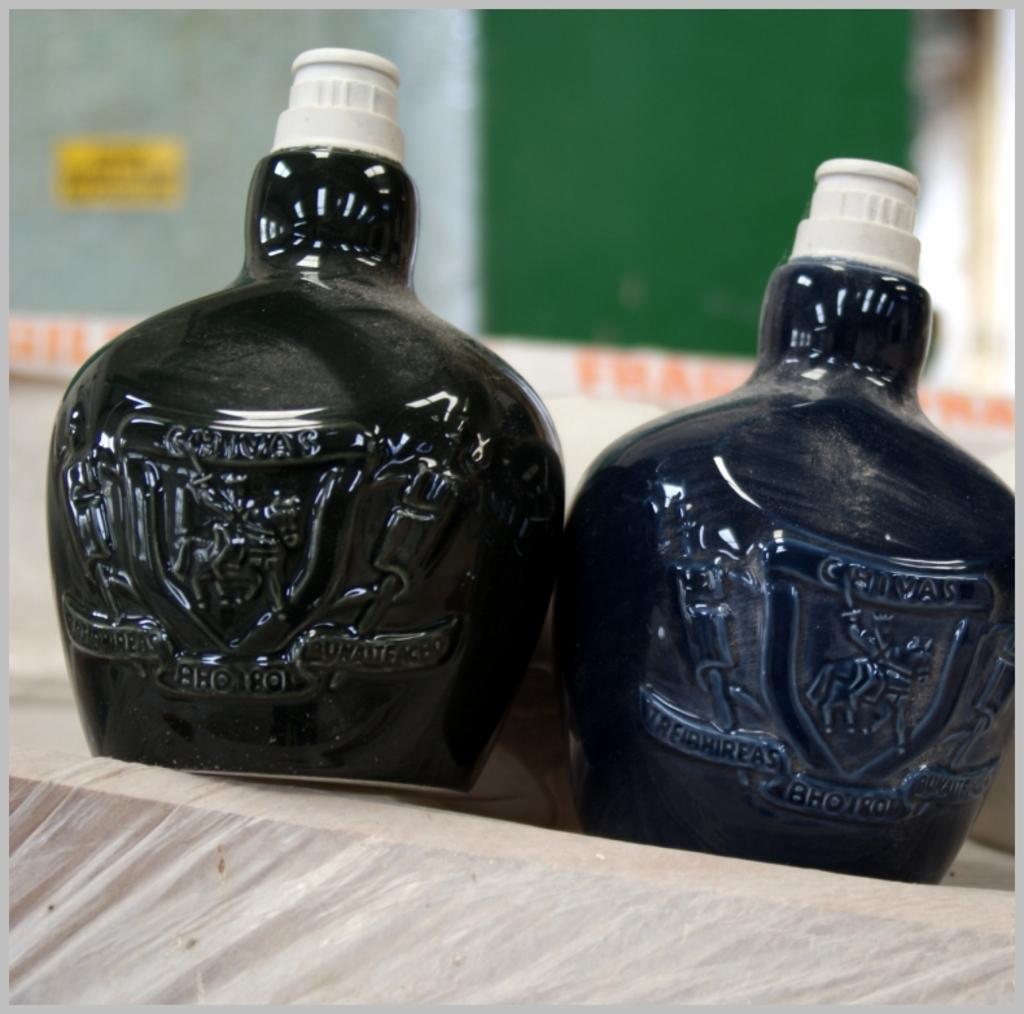What brand are these drinks as shown on the top of the shield?
Your answer should be very brief. Chivas. The brand is nice?
Offer a very short reply. Unanswerable. 